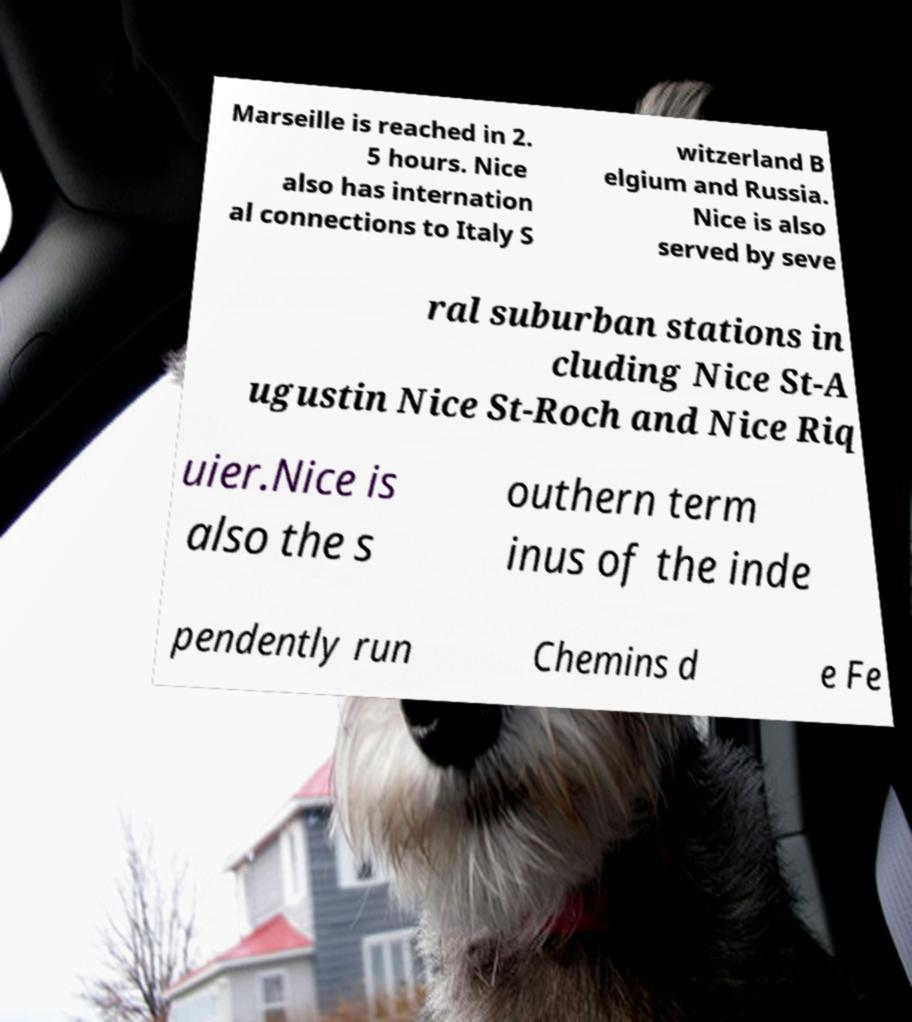Could you assist in decoding the text presented in this image and type it out clearly? Marseille is reached in 2. 5 hours. Nice also has internation al connections to Italy S witzerland B elgium and Russia. Nice is also served by seve ral suburban stations in cluding Nice St-A ugustin Nice St-Roch and Nice Riq uier.Nice is also the s outhern term inus of the inde pendently run Chemins d e Fe 